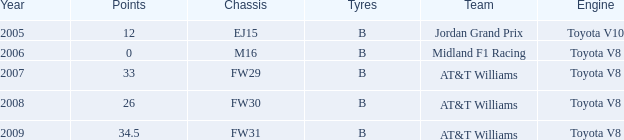In which initial year did a toyota v8 engine have fewer than 26 points? 2006.0. 